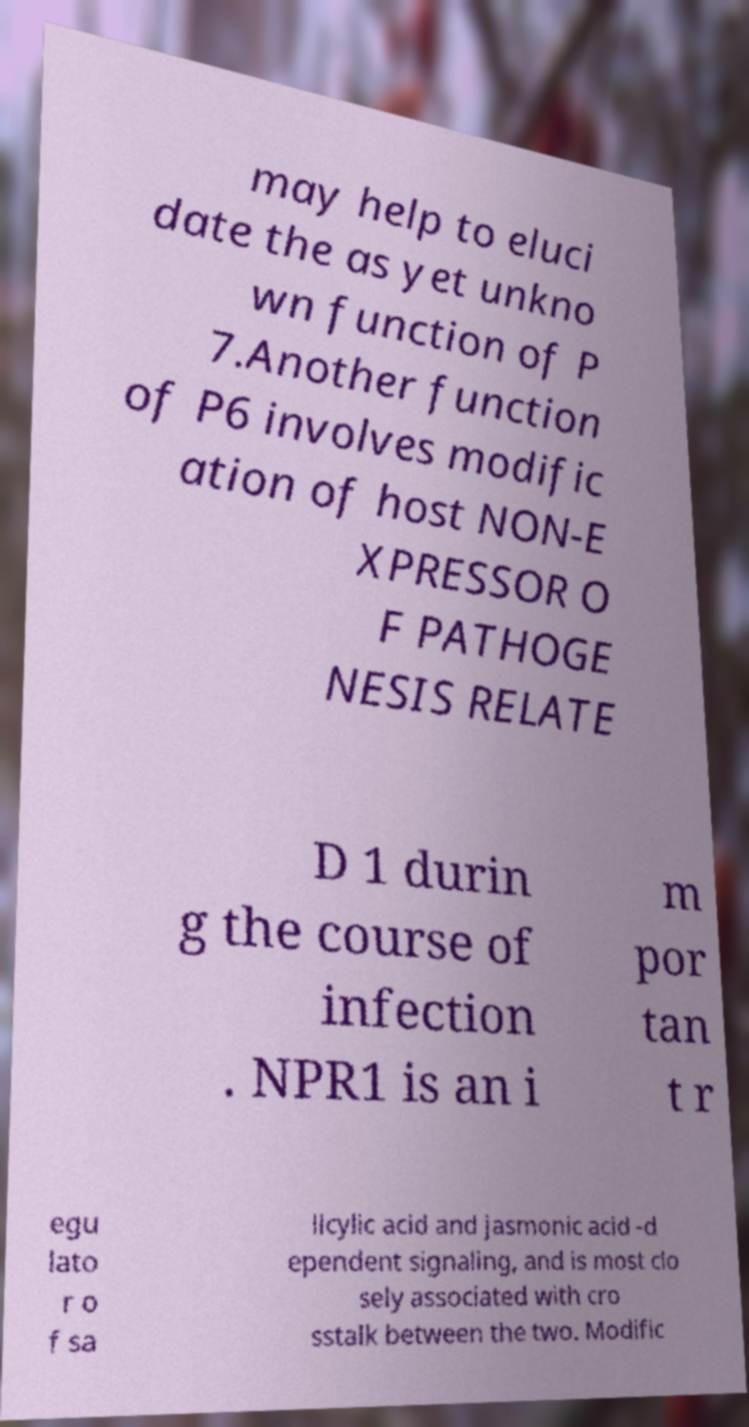For documentation purposes, I need the text within this image transcribed. Could you provide that? may help to eluci date the as yet unkno wn function of P 7.Another function of P6 involves modific ation of host NON-E XPRESSOR O F PATHOGE NESIS RELATE D 1 durin g the course of infection . NPR1 is an i m por tan t r egu lato r o f sa licylic acid and jasmonic acid -d ependent signaling, and is most clo sely associated with cro sstalk between the two. Modific 